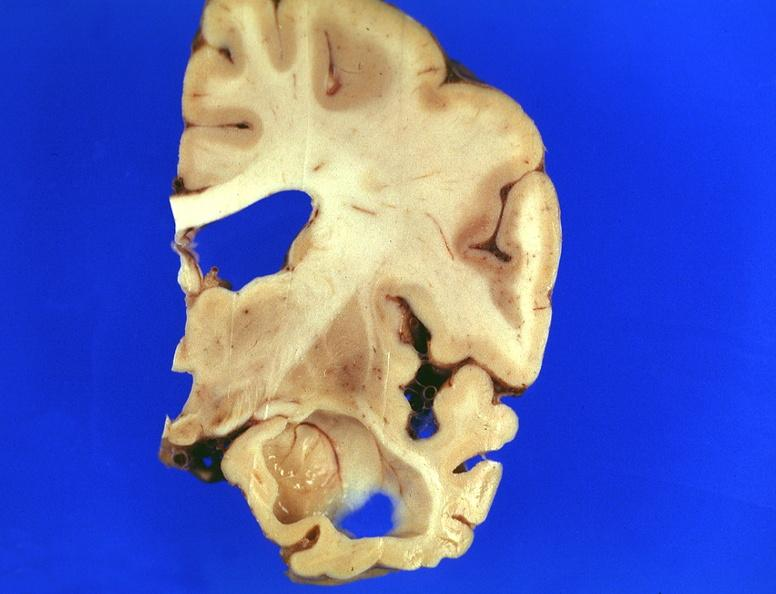does apoptosis tunel show brain, frontal lobe atrophy, pick 's disease?
Answer the question using a single word or phrase. No 